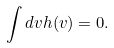Convert formula to latex. <formula><loc_0><loc_0><loc_500><loc_500>\int d v h ( v ) = 0 .</formula> 